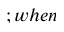<formula> <loc_0><loc_0><loc_500><loc_500>; w h e n</formula> 